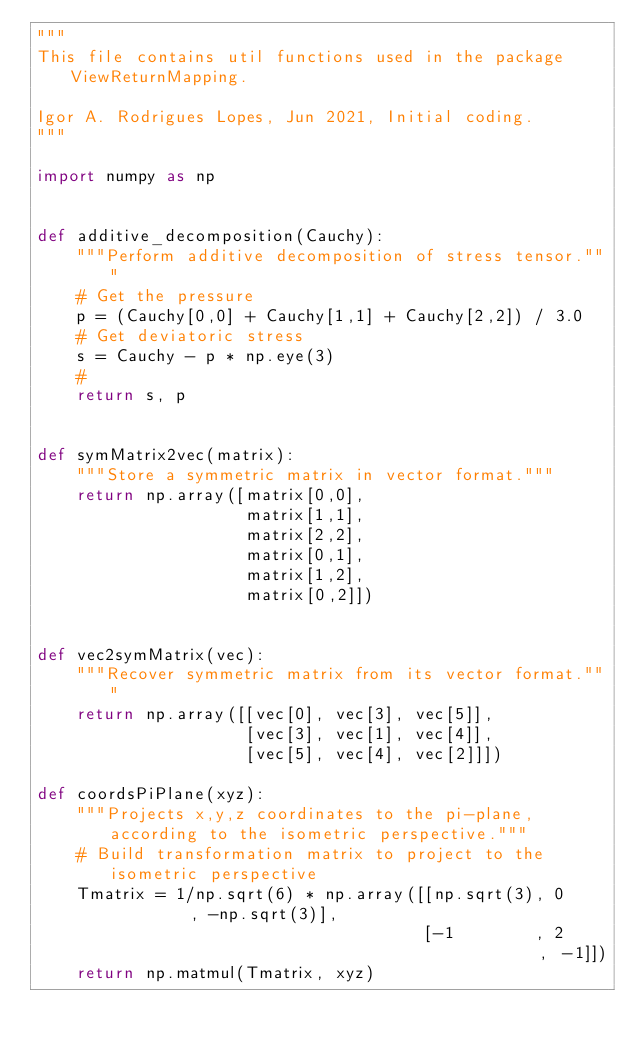Convert code to text. <code><loc_0><loc_0><loc_500><loc_500><_Python_>"""
This file contains util functions used in the package ViewReturnMapping.

Igor A. Rodrigues Lopes, Jun 2021, Initial coding.
"""

import numpy as np


def additive_decomposition(Cauchy):
    """Perform additive decomposition of stress tensor."""
    # Get the pressure
    p = (Cauchy[0,0] + Cauchy[1,1] + Cauchy[2,2]) / 3.0
    # Get deviatoric stress
    s = Cauchy - p * np.eye(3)
    #
    return s, p


def symMatrix2vec(matrix):
    """Store a symmetric matrix in vector format."""
    return np.array([matrix[0,0],
                     matrix[1,1],
                     matrix[2,2],
                     matrix[0,1],
                     matrix[1,2],
                     matrix[0,2]])


def vec2symMatrix(vec):
    """Recover symmetric matrix from its vector format."""
    return np.array([[vec[0], vec[3], vec[5]],
                     [vec[3], vec[1], vec[4]],
                     [vec[5], vec[4], vec[2]]])

def coordsPiPlane(xyz):
    """Projects x,y,z coordinates to the pi-plane, according to the isometric perspective."""
    # Build transformation matrix to project to the isometric perspective
    Tmatrix = 1/np.sqrt(6) * np.array([[np.sqrt(3), 0         , -np.sqrt(3)],
                                       [-1        , 2         , -1]])
    return np.matmul(Tmatrix, xyz)</code> 